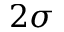<formula> <loc_0><loc_0><loc_500><loc_500>2 \sigma</formula> 